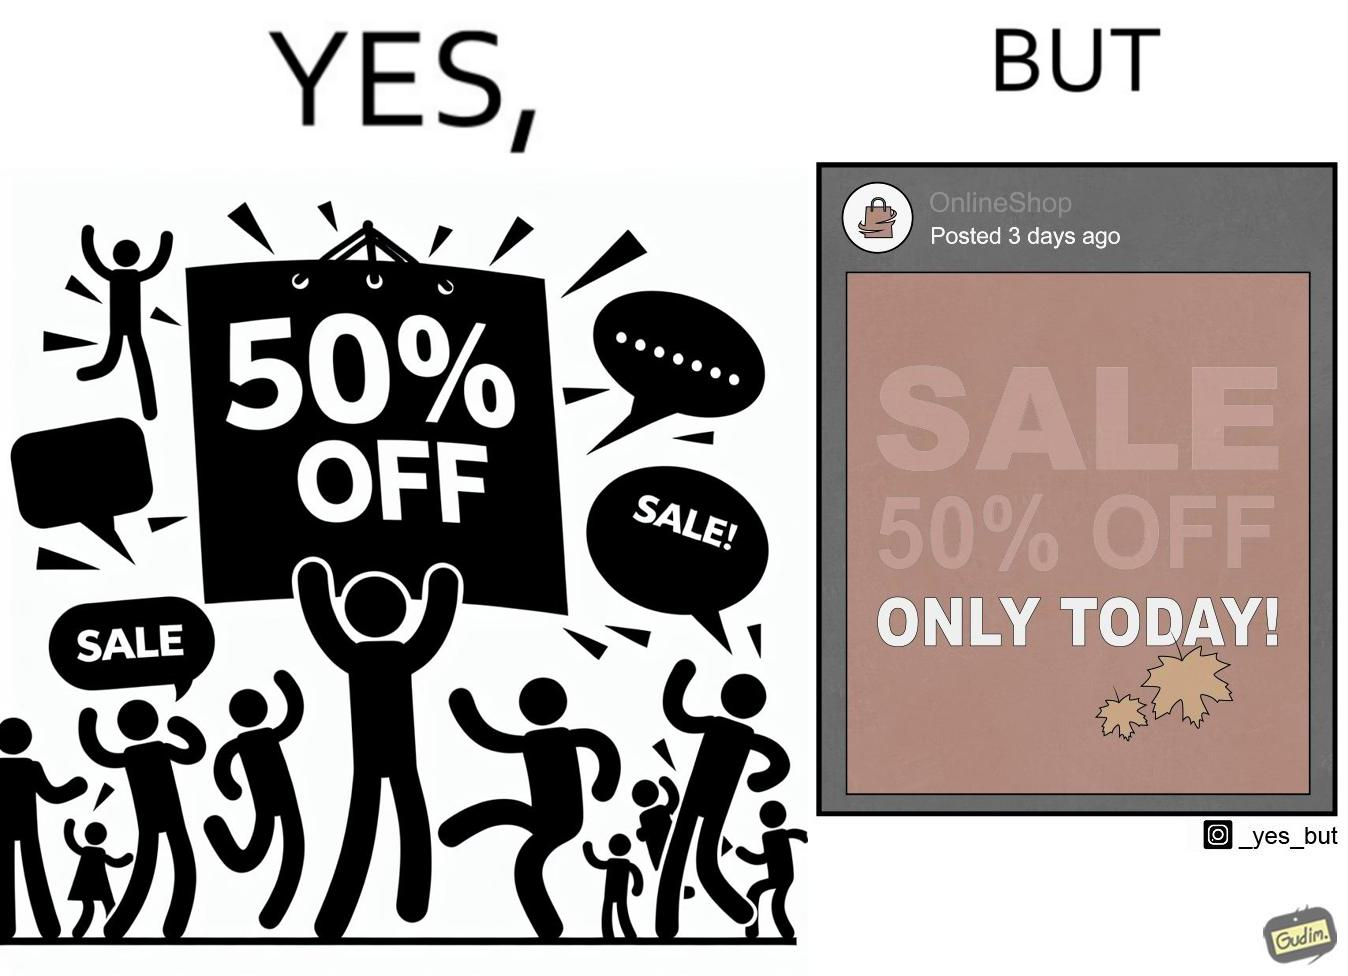Provide a description of this image. The image is ironic, because the poster of sale at a store is posted 3 days ago on a social media account which means the sale which was for only one day has become over 